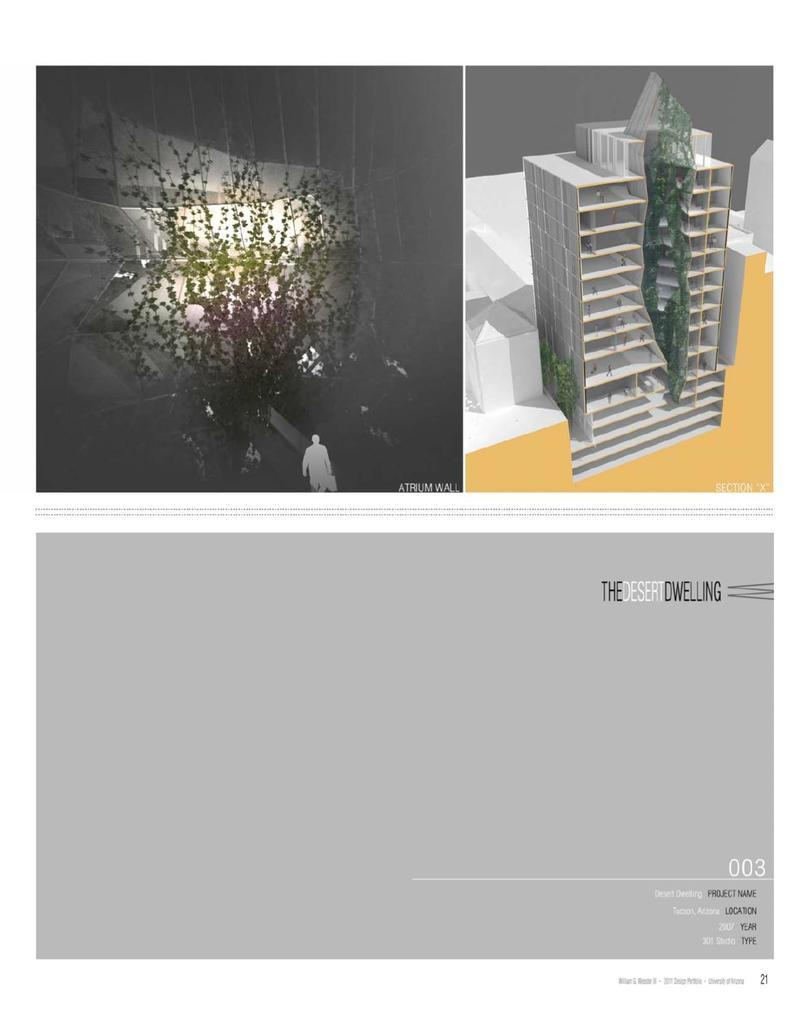What type of structure is present in the image? There is a building in the image. What colors can be seen on the building? The building has white and gray colors. What natural element is visible in the image? There is a tree in the image. What type of artwork is present in the scene? There is a collage image in the scene. Where is the flame located in the image? There is no flame present in the image. What type of heart can be seen in the image? There is no heart present in the image. 